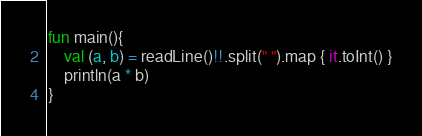Convert code to text. <code><loc_0><loc_0><loc_500><loc_500><_Kotlin_>fun main(){
    val (a, b) = readLine()!!.split(" ").map { it.toInt() }
    println(a * b)
}
</code> 